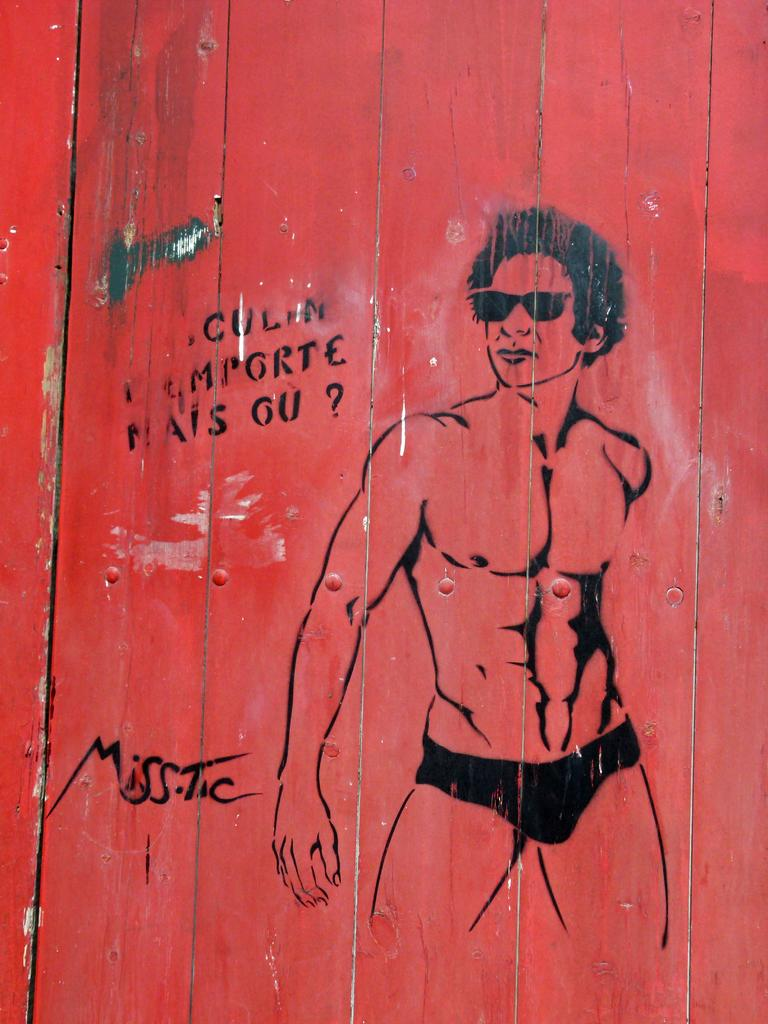What type of material is used for the wall in the image? There is a wooden wall in the image. What can be seen on the wooden wall? There is some art and text on the wall. What type of shoes are hanging on the wooden wall in the image? There are no shoes present on the wooden wall in the image. 